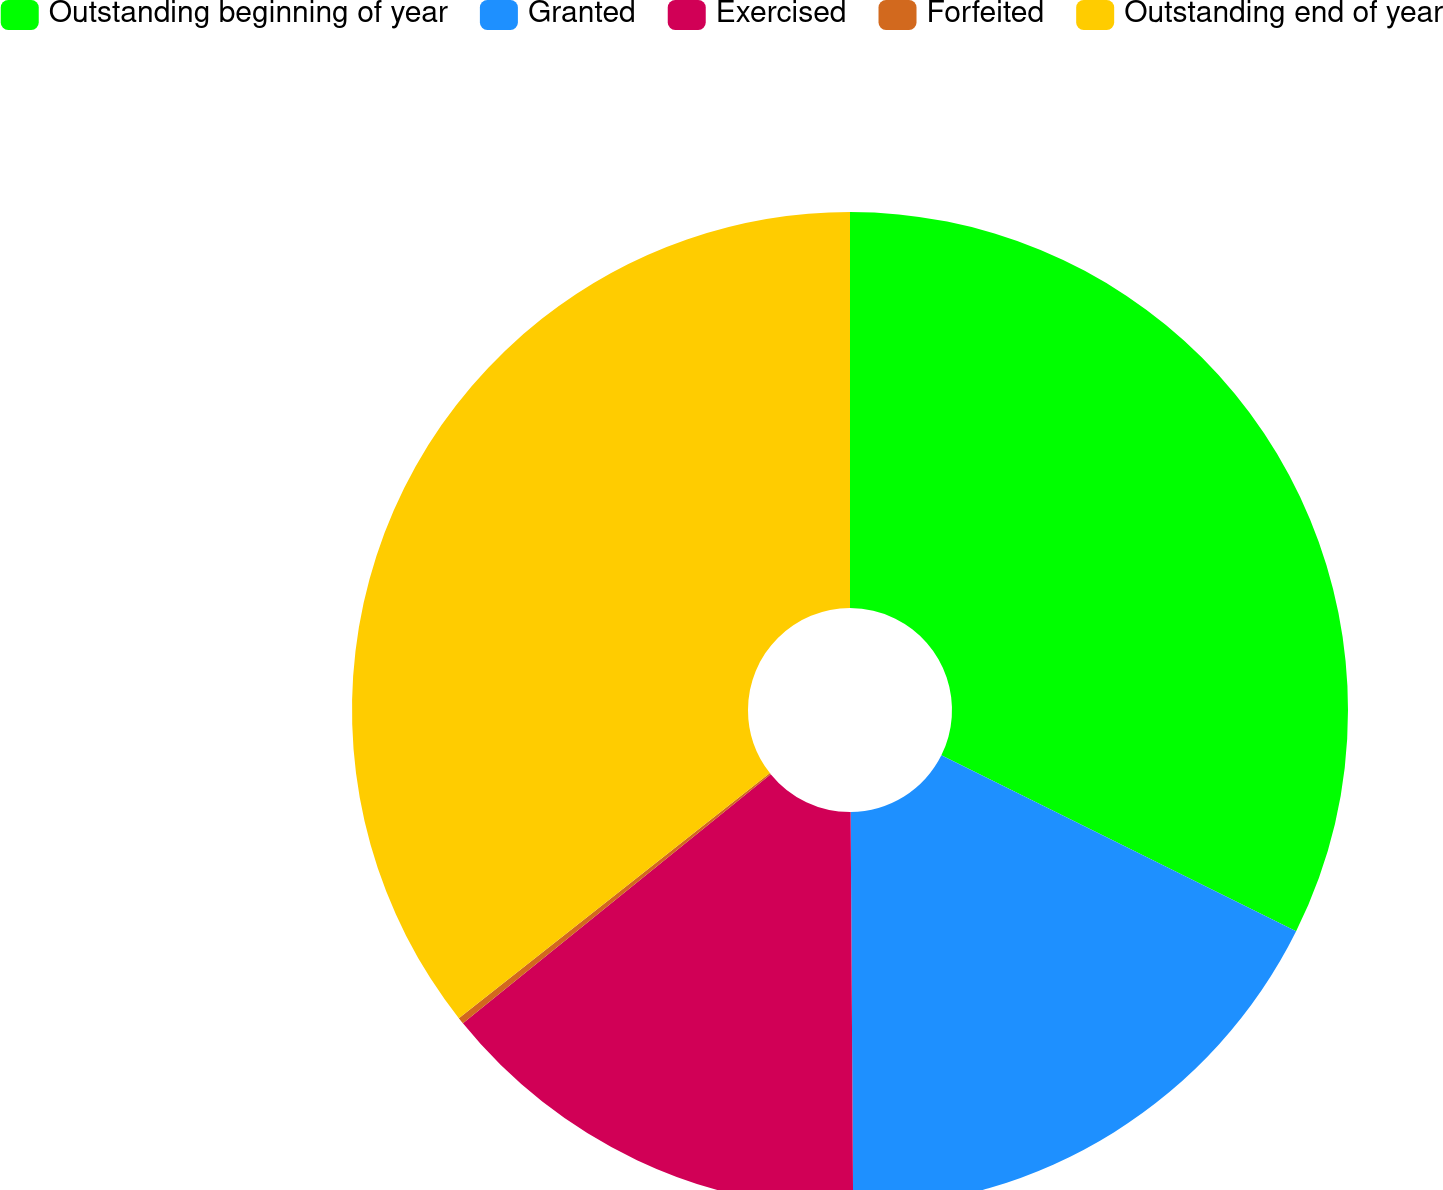Convert chart to OTSL. <chart><loc_0><loc_0><loc_500><loc_500><pie_chart><fcel>Outstanding beginning of year<fcel>Granted<fcel>Exercised<fcel>Forfeited<fcel>Outstanding end of year<nl><fcel>32.33%<fcel>17.57%<fcel>14.27%<fcel>0.21%<fcel>35.62%<nl></chart> 